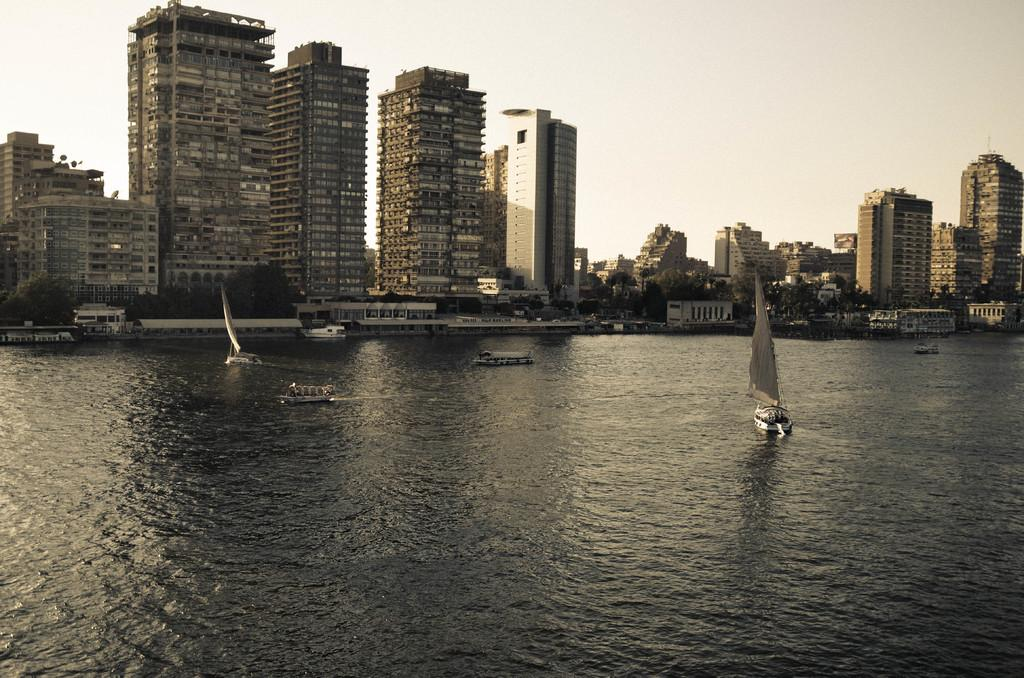What is present on the river in the image? There are ships on the river in the image. What can be seen in the background of the image? There are buildings and the sky visible in the background of the image. What type of cart is being used to teach the ships in the image? There is no cart or teaching activity present in the image; it features ships on a river with buildings and the sky in the background. 